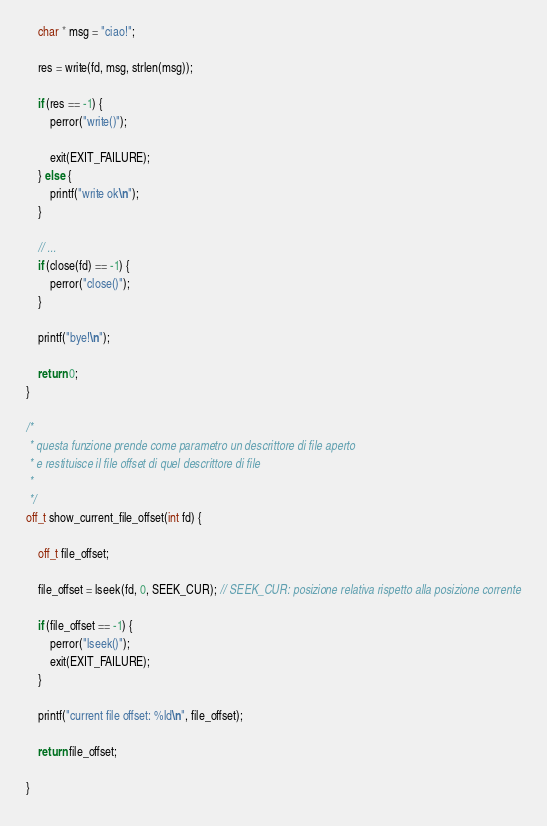<code> <loc_0><loc_0><loc_500><loc_500><_C_>
	char * msg = "ciao!";

	res = write(fd, msg, strlen(msg));

	if (res == -1) {
		perror("write()");

		exit(EXIT_FAILURE);
	} else {
		printf("write ok\n");
	}

	// ...
	if (close(fd) == -1) {
		perror("close()");
	}

	printf("bye!\n");

	return 0;
}

/*
 * questa funzione prende come parametro un descrittore di file aperto
 * e restituisce il file offset di quel descrittore di file
 *
 */
off_t show_current_file_offset(int fd) {

	off_t file_offset;

	file_offset = lseek(fd, 0, SEEK_CUR); // SEEK_CUR: posizione relativa rispetto alla posizione corrente

	if (file_offset == -1) {
		perror("lseek()");
		exit(EXIT_FAILURE);
	}

	printf("current file offset: %ld\n", file_offset);

	return file_offset;

}
</code> 